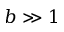<formula> <loc_0><loc_0><loc_500><loc_500>b \gg 1</formula> 